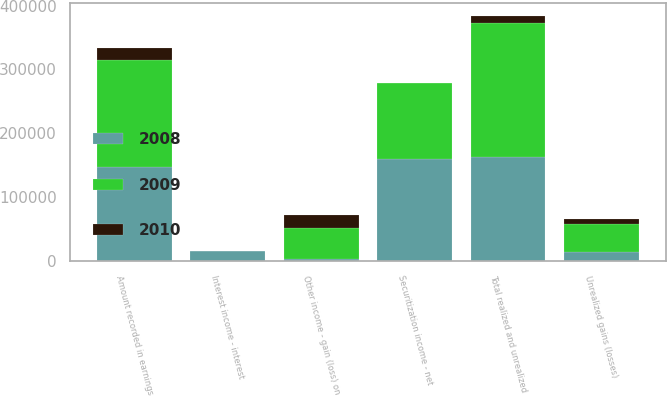Convert chart. <chart><loc_0><loc_0><loc_500><loc_500><stacked_bar_chart><ecel><fcel>Interest income - interest<fcel>Other income - gain (loss) on<fcel>Securitization income - net<fcel>Amount recorded in earnings<fcel>Unrealized gains (losses)<fcel>Total realized and unrealized<nl><fcel>2010<fcel>0<fcel>19556<fcel>0<fcel>19556<fcel>7455<fcel>12101<nl><fcel>2008<fcel>15569<fcel>2837<fcel>160087<fcel>147355<fcel>14909<fcel>162264<nl><fcel>2009<fcel>104<fcel>49095<fcel>117943<fcel>166934<fcel>42881<fcel>209815<nl></chart> 